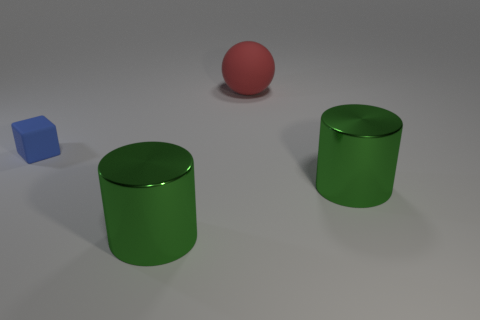Add 2 big red things. How many objects exist? 6 Subtract all cubes. How many objects are left? 3 Subtract all small things. Subtract all red balls. How many objects are left? 2 Add 2 rubber things. How many rubber things are left? 4 Add 3 green objects. How many green objects exist? 5 Subtract 0 cyan spheres. How many objects are left? 4 